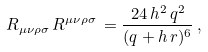Convert formula to latex. <formula><loc_0><loc_0><loc_500><loc_500>R _ { \mu \nu \rho \sigma } \, R ^ { \mu \nu \rho \sigma } \, = \frac { 2 4 \, h ^ { 2 } \, q ^ { 2 } } { ( q + h \, r ) ^ { 6 } } \, ,</formula> 